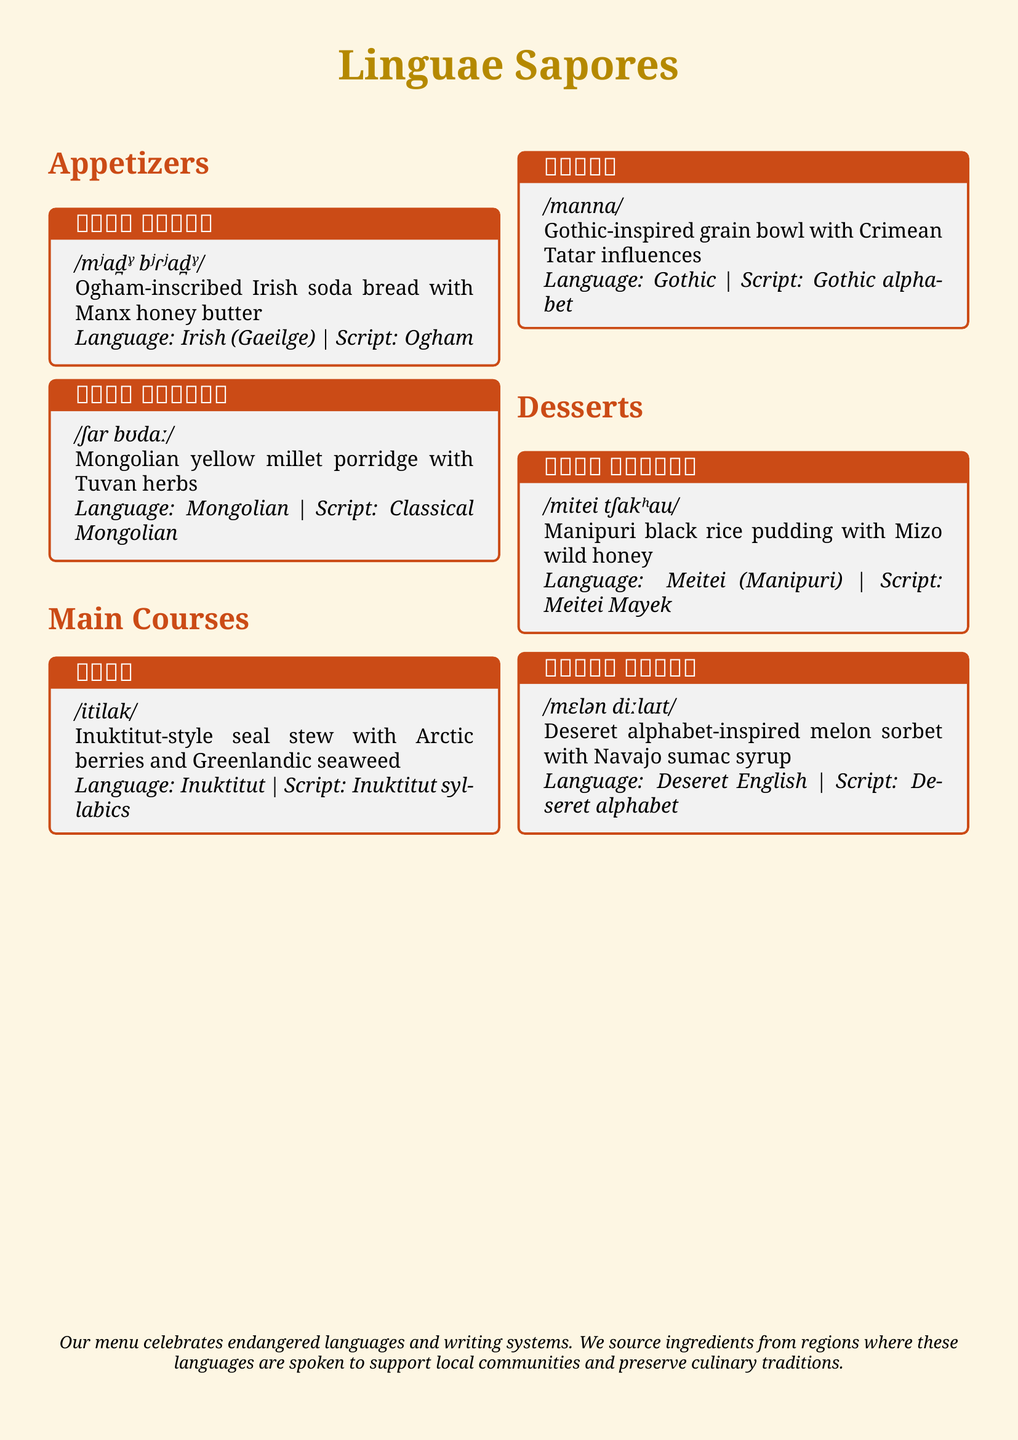What is the title of the menu? The title of the menu is prominently featured at the top in large font.
Answer: Linguae Sapores How many appetizers are listed on the menu? The menu lists a total of two appetizers in the appetizers section.
Answer: 2 What is the language of the dish ᚋᚓᚐᚇ ᚁᚏᚓᚐᚇ? The dish name is associated with a specific language as noted in the description.
Answer: Irish (Gaeilge) What is the phonetic pronunciation of 𐐣𐐯𐑊𐐲𐑌 𐐔𐐨𐑊𐐴𐐻? Each dish includes its phonetic pronunciation written in slashes for easy reading.
Answer: /mɛlən diːlaɪt/ Which script is used for the dish ᠰᠢᠷᠠ ᠪᠤᠳᠠᠭᠠ? Each dish's writing system is mentioned right after the dish name.
Answer: Classical Mongolian What is the main ingredient in the dessert  ꯃꯤꯇꯩ ꯆꯥꯛꯍꯥꯎ? The main ingredient is highlighted in the description of the dessert.
Answer: Black rice What language is the dish ᐃᑎᓕᒃ associated with? Each dish includes a language attribution that identifies its cultural origin.
Answer: Inuktitut What are the two elements included in the dish 𐌼𐌰𐌽𐌽𐌰? Each dish features key ingredients, providing insight into its flavors and inspirations.
Answer: Grain bowl, Crimean Tatar influences 